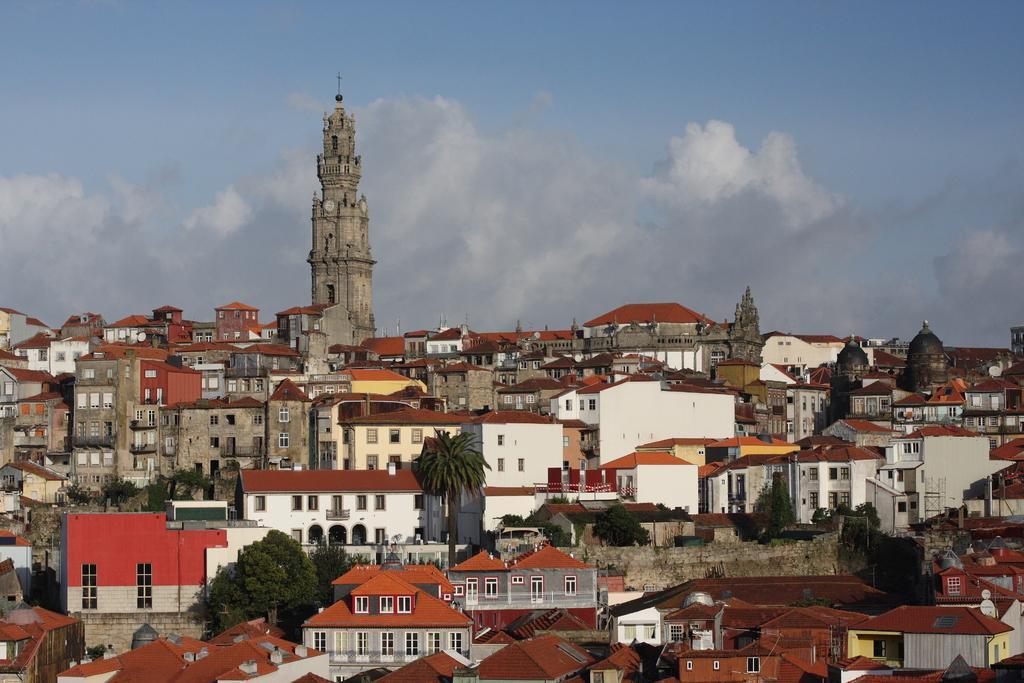How would you summarize this image in a sentence or two? In this image there are buildings in the middle there are tree, in the background there is a church and the sky. 